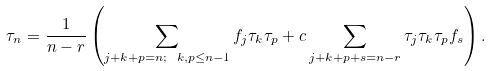<formula> <loc_0><loc_0><loc_500><loc_500>\tau _ { n } = \frac { 1 } { n - r } \left ( \sum _ { j + k + p = n ; \ k , p \leq n - 1 } f _ { j } \tau _ { k } \tau _ { p } + c \sum _ { j + k + p + s = n - r } \tau _ { j } \tau _ { k } \tau _ { p } f _ { s } \right ) .</formula> 